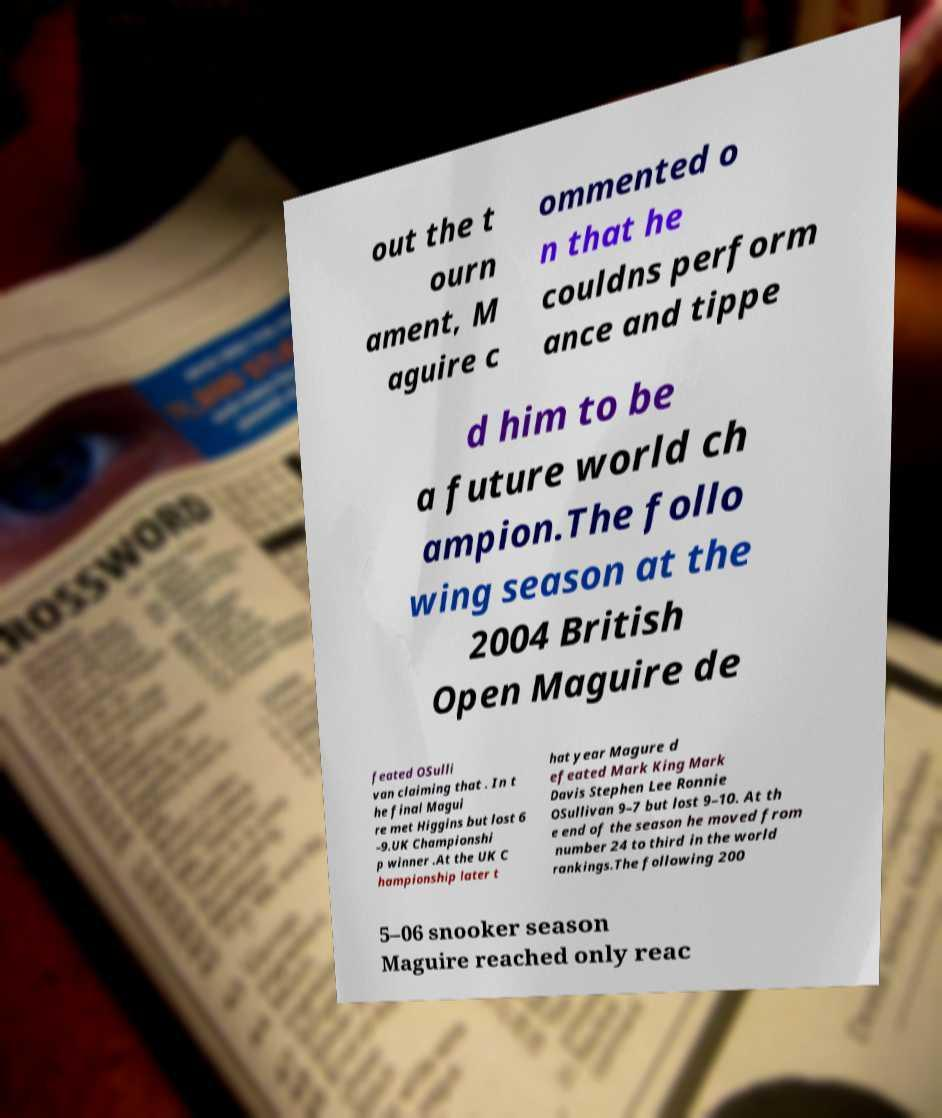I need the written content from this picture converted into text. Can you do that? out the t ourn ament, M aguire c ommented o n that he couldns perform ance and tippe d him to be a future world ch ampion.The follo wing season at the 2004 British Open Maguire de feated OSulli van claiming that . In t he final Magui re met Higgins but lost 6 –9.UK Championshi p winner .At the UK C hampionship later t hat year Magure d efeated Mark King Mark Davis Stephen Lee Ronnie OSullivan 9–7 but lost 9–10. At th e end of the season he moved from number 24 to third in the world rankings.The following 200 5–06 snooker season Maguire reached only reac 